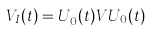<formula> <loc_0><loc_0><loc_500><loc_500>V _ { I } ( t ) = U _ { 0 } ^ { \dagger } ( t ) V U _ { 0 } ( t )</formula> 